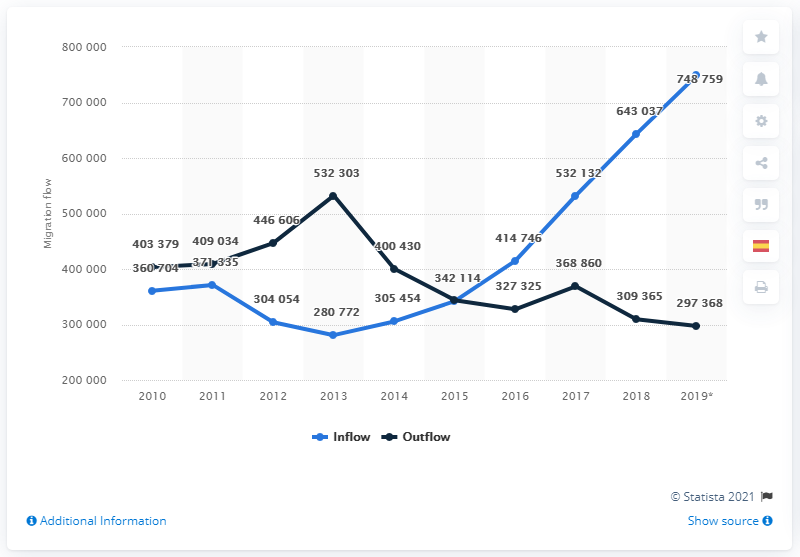Indicate a few pertinent items in this graphic. The downward trend in the population of Spain ceased in 2016. 